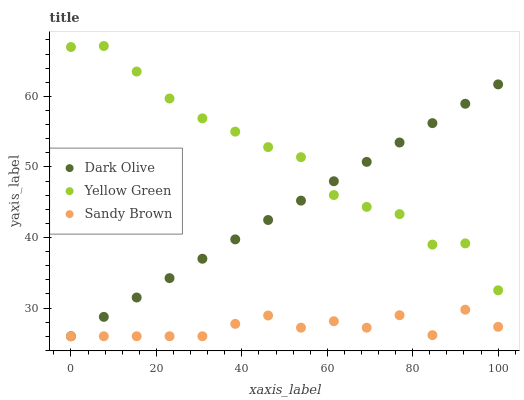Does Sandy Brown have the minimum area under the curve?
Answer yes or no. Yes. Does Yellow Green have the maximum area under the curve?
Answer yes or no. Yes. Does Yellow Green have the minimum area under the curve?
Answer yes or no. No. Does Sandy Brown have the maximum area under the curve?
Answer yes or no. No. Is Dark Olive the smoothest?
Answer yes or no. Yes. Is Yellow Green the roughest?
Answer yes or no. Yes. Is Sandy Brown the smoothest?
Answer yes or no. No. Is Sandy Brown the roughest?
Answer yes or no. No. Does Dark Olive have the lowest value?
Answer yes or no. Yes. Does Yellow Green have the lowest value?
Answer yes or no. No. Does Yellow Green have the highest value?
Answer yes or no. Yes. Does Sandy Brown have the highest value?
Answer yes or no. No. Is Sandy Brown less than Yellow Green?
Answer yes or no. Yes. Is Yellow Green greater than Sandy Brown?
Answer yes or no. Yes. Does Dark Olive intersect Yellow Green?
Answer yes or no. Yes. Is Dark Olive less than Yellow Green?
Answer yes or no. No. Is Dark Olive greater than Yellow Green?
Answer yes or no. No. Does Sandy Brown intersect Yellow Green?
Answer yes or no. No. 